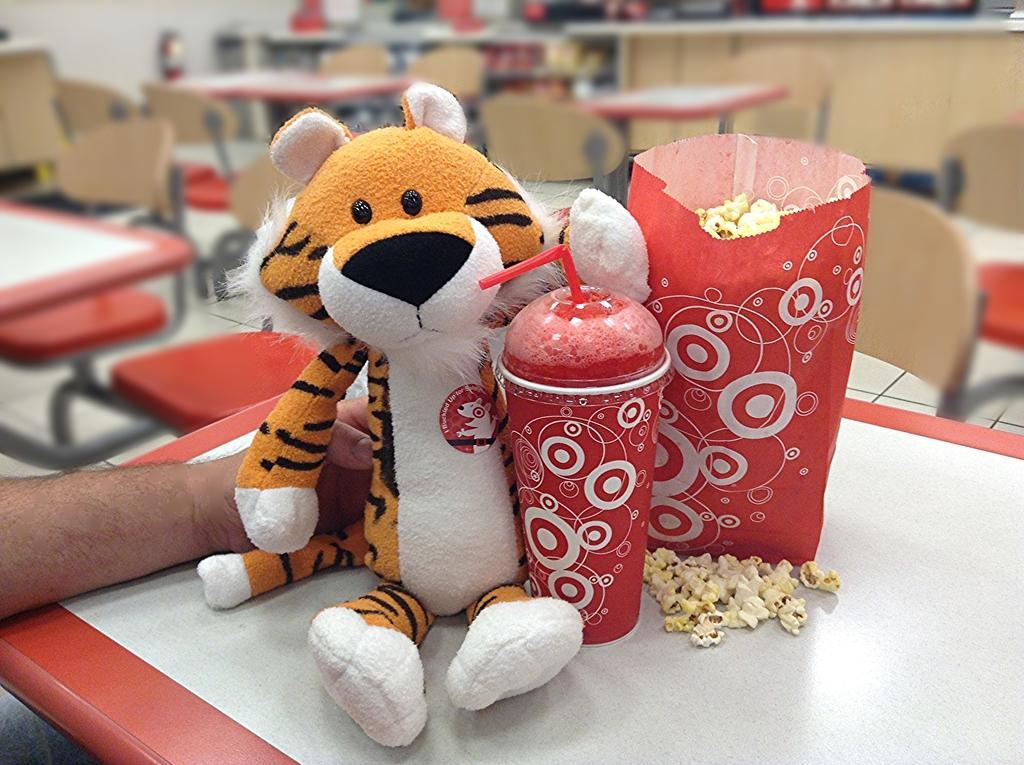Can you describe this image briefly? In this image we can see a person's hand holding a toy, we can see tin with straw, popcorn cover are kept on the table. The background of the image is blurred, where we can see tables and chairs. 